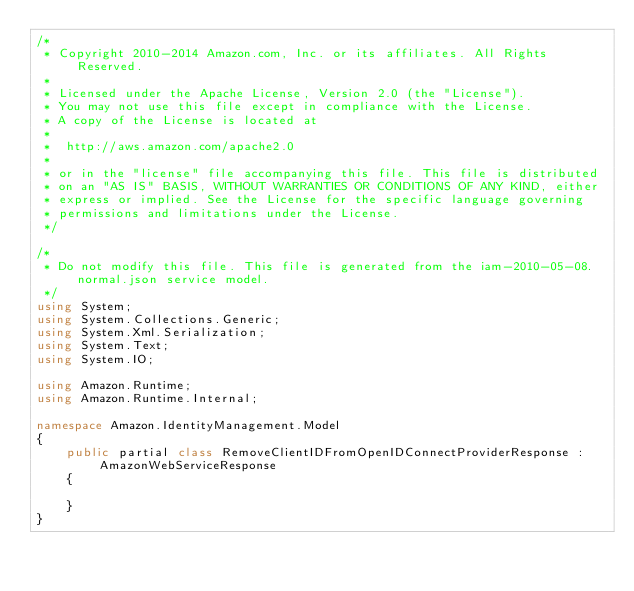<code> <loc_0><loc_0><loc_500><loc_500><_C#_>/*
 * Copyright 2010-2014 Amazon.com, Inc. or its affiliates. All Rights Reserved.
 * 
 * Licensed under the Apache License, Version 2.0 (the "License").
 * You may not use this file except in compliance with the License.
 * A copy of the License is located at
 * 
 *  http://aws.amazon.com/apache2.0
 * 
 * or in the "license" file accompanying this file. This file is distributed
 * on an "AS IS" BASIS, WITHOUT WARRANTIES OR CONDITIONS OF ANY KIND, either
 * express or implied. See the License for the specific language governing
 * permissions and limitations under the License.
 */

/*
 * Do not modify this file. This file is generated from the iam-2010-05-08.normal.json service model.
 */
using System;
using System.Collections.Generic;
using System.Xml.Serialization;
using System.Text;
using System.IO;

using Amazon.Runtime;
using Amazon.Runtime.Internal;

namespace Amazon.IdentityManagement.Model
{
    public partial class RemoveClientIDFromOpenIDConnectProviderResponse : AmazonWebServiceResponse
    {

    }
}</code> 